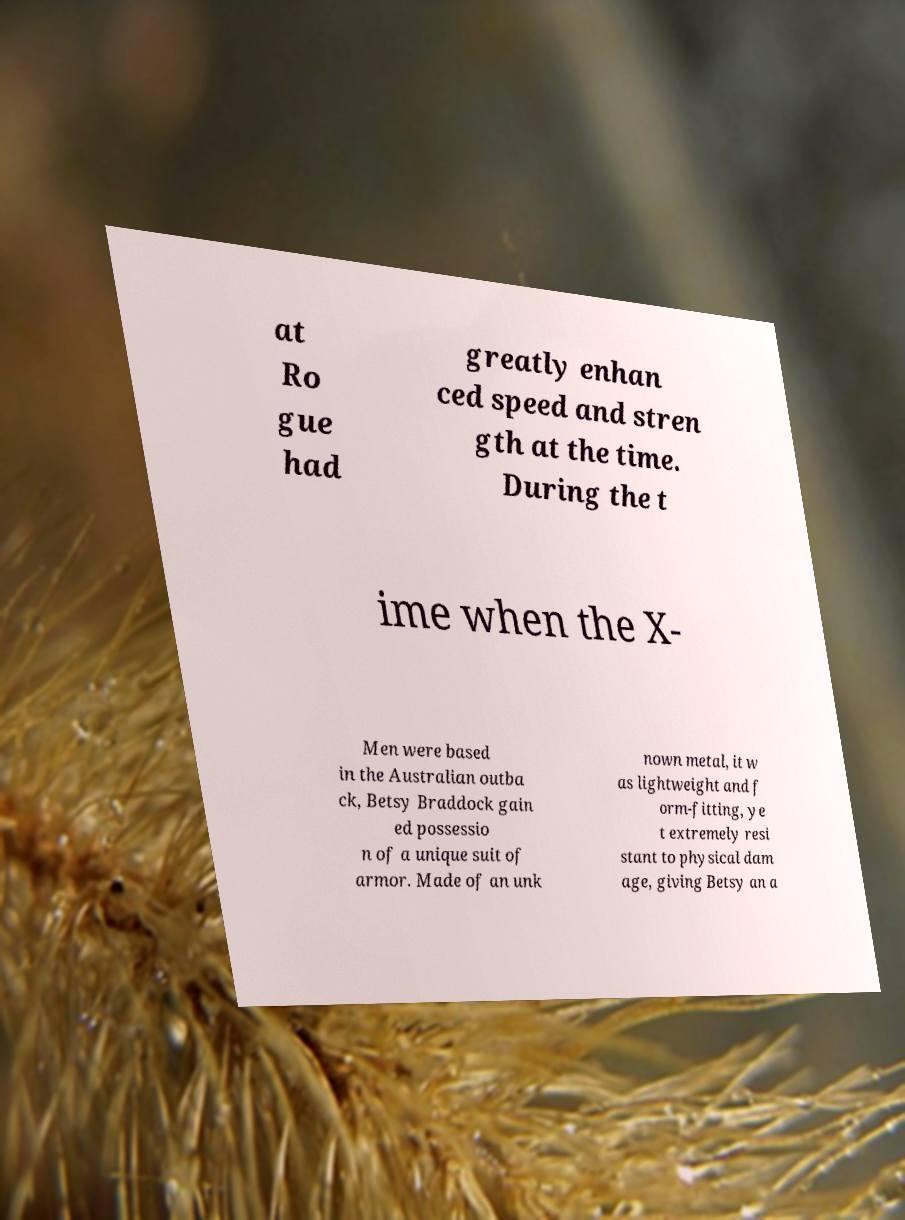Can you read and provide the text displayed in the image?This photo seems to have some interesting text. Can you extract and type it out for me? at Ro gue had greatly enhan ced speed and stren gth at the time. During the t ime when the X- Men were based in the Australian outba ck, Betsy Braddock gain ed possessio n of a unique suit of armor. Made of an unk nown metal, it w as lightweight and f orm-fitting, ye t extremely resi stant to physical dam age, giving Betsy an a 